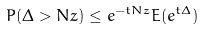Convert formula to latex. <formula><loc_0><loc_0><loc_500><loc_500>P ( \Delta > N z ) \leq e ^ { - t N z } E ( e ^ { t \Delta } )</formula> 